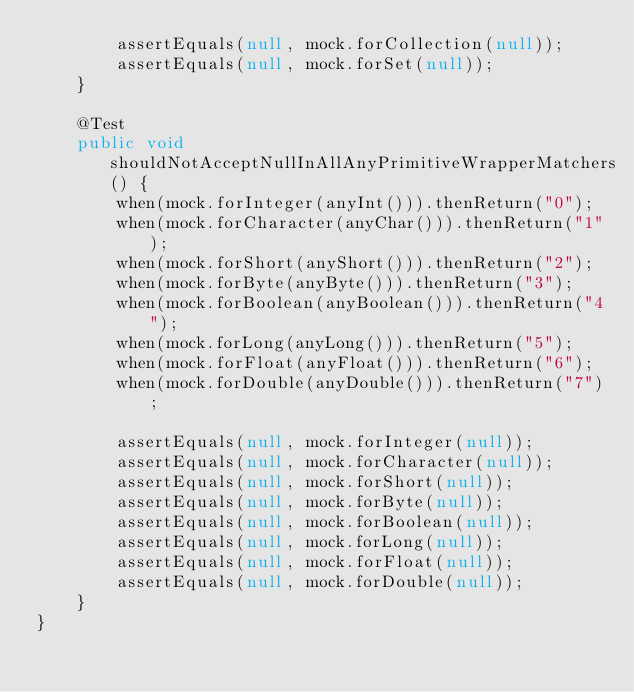<code> <loc_0><loc_0><loc_500><loc_500><_Java_>        assertEquals(null, mock.forCollection(null));
        assertEquals(null, mock.forSet(null));
    }
    
    @Test
    public void shouldNotAcceptNullInAllAnyPrimitiveWrapperMatchers() {
        when(mock.forInteger(anyInt())).thenReturn("0");
        when(mock.forCharacter(anyChar())).thenReturn("1");
        when(mock.forShort(anyShort())).thenReturn("2");
        when(mock.forByte(anyByte())).thenReturn("3");
        when(mock.forBoolean(anyBoolean())).thenReturn("4");
        when(mock.forLong(anyLong())).thenReturn("5");
        when(mock.forFloat(anyFloat())).thenReturn("6");
        when(mock.forDouble(anyDouble())).thenReturn("7");
        
        assertEquals(null, mock.forInteger(null));
        assertEquals(null, mock.forCharacter(null));
        assertEquals(null, mock.forShort(null));
        assertEquals(null, mock.forByte(null));
        assertEquals(null, mock.forBoolean(null));
        assertEquals(null, mock.forLong(null));
        assertEquals(null, mock.forFloat(null));
        assertEquals(null, mock.forDouble(null));
    }
}</code> 